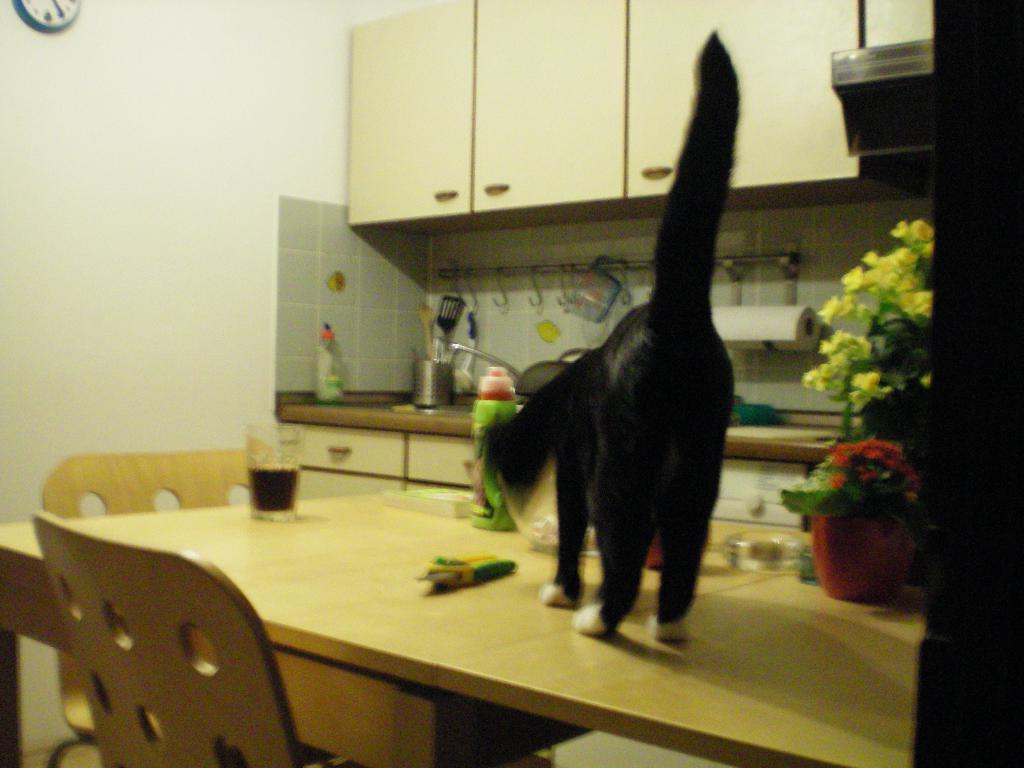Could you give a brief overview of what you see in this image? In the picture I can see a cat is standing on the table. On the table I can see glasses, flower pot and some other objects on it. In the background I can see wooden cupboard, kitchen table which has some objects on it. I can also see a wall which has a clock attached to it and some other objects. 